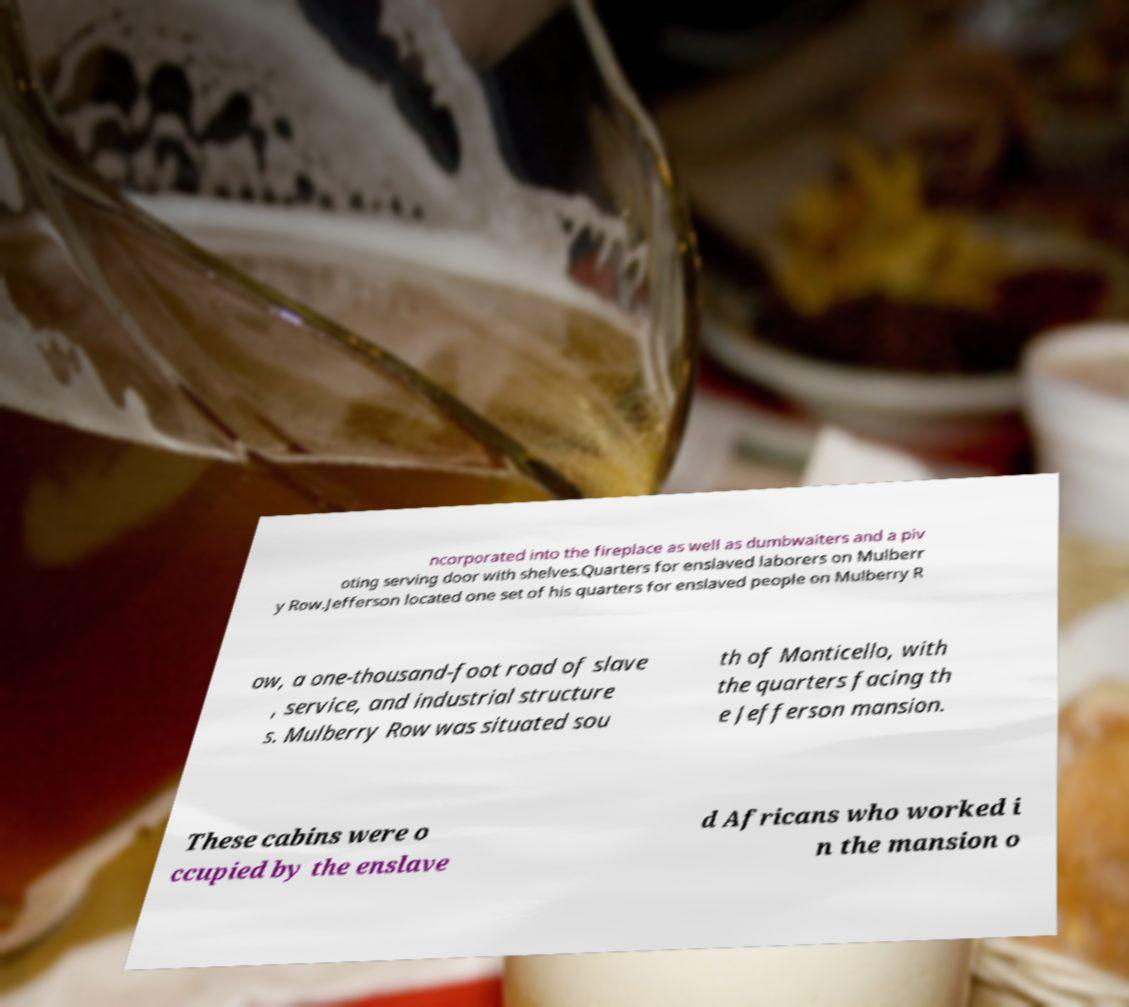There's text embedded in this image that I need extracted. Can you transcribe it verbatim? ncorporated into the fireplace as well as dumbwaiters and a piv oting serving door with shelves.Quarters for enslaved laborers on Mulberr y Row.Jefferson located one set of his quarters for enslaved people on Mulberry R ow, a one-thousand-foot road of slave , service, and industrial structure s. Mulberry Row was situated sou th of Monticello, with the quarters facing th e Jefferson mansion. These cabins were o ccupied by the enslave d Africans who worked i n the mansion o 